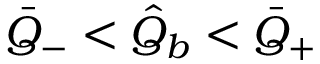Convert formula to latex. <formula><loc_0><loc_0><loc_500><loc_500>\bar { Q } _ { - } < \hat { Q } _ { b } < \bar { Q } _ { + }</formula> 